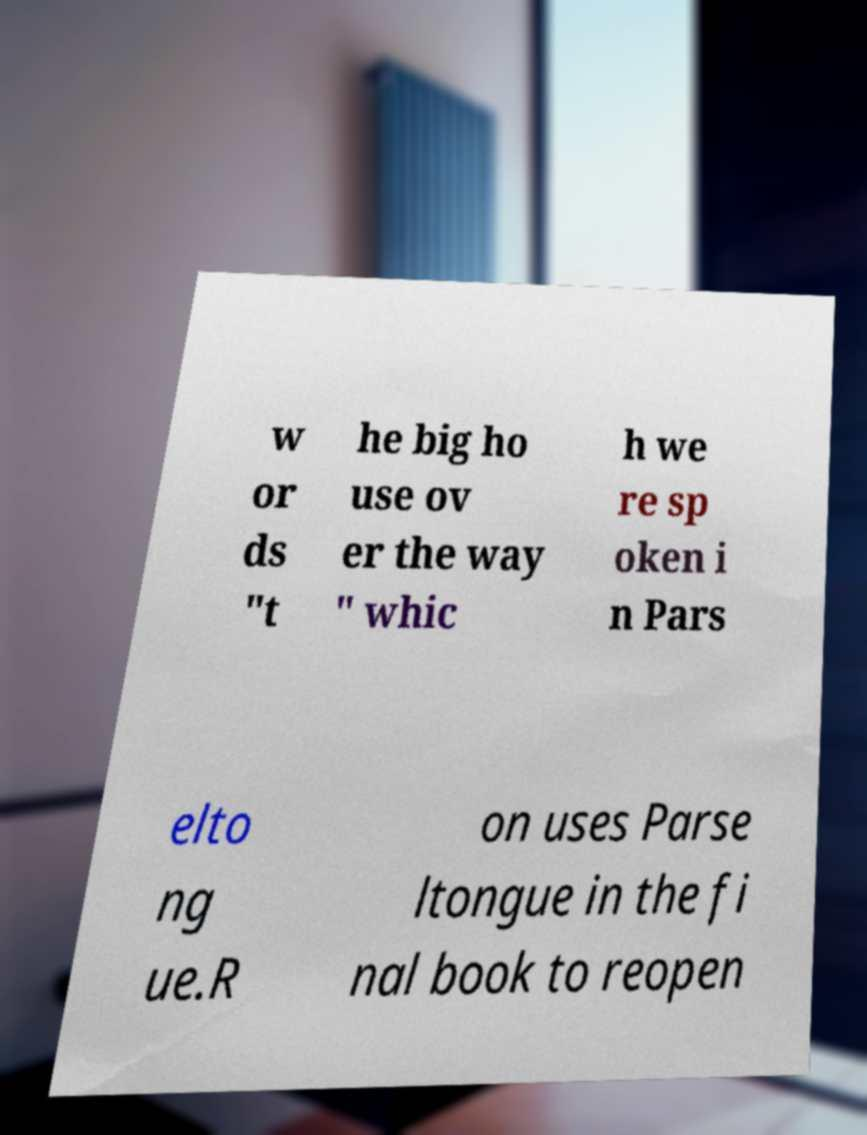There's text embedded in this image that I need extracted. Can you transcribe it verbatim? w or ds "t he big ho use ov er the way " whic h we re sp oken i n Pars elto ng ue.R on uses Parse ltongue in the fi nal book to reopen 